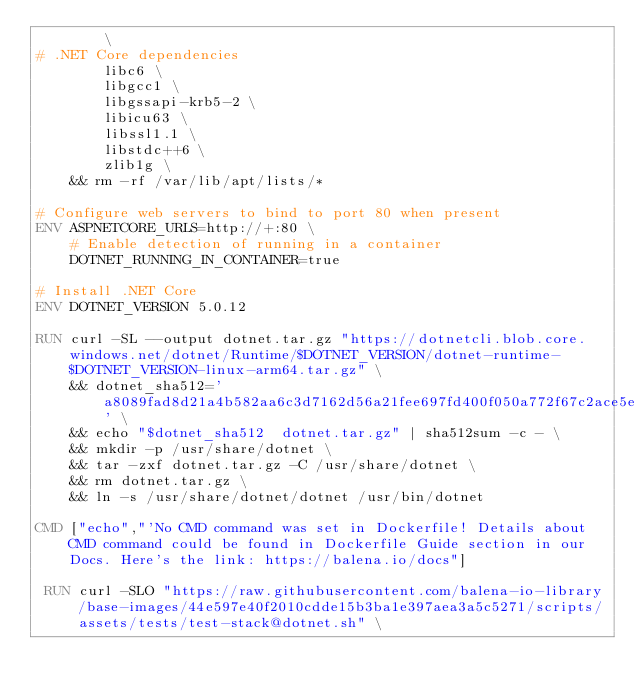<code> <loc_0><loc_0><loc_500><loc_500><_Dockerfile_>        \
# .NET Core dependencies
        libc6 \
        libgcc1 \
        libgssapi-krb5-2 \
        libicu63 \
        libssl1.1 \
        libstdc++6 \
        zlib1g \
    && rm -rf /var/lib/apt/lists/*

# Configure web servers to bind to port 80 when present
ENV ASPNETCORE_URLS=http://+:80 \
    # Enable detection of running in a container
    DOTNET_RUNNING_IN_CONTAINER=true

# Install .NET Core
ENV DOTNET_VERSION 5.0.12

RUN curl -SL --output dotnet.tar.gz "https://dotnetcli.blob.core.windows.net/dotnet/Runtime/$DOTNET_VERSION/dotnet-runtime-$DOTNET_VERSION-linux-arm64.tar.gz" \
    && dotnet_sha512='a8089fad8d21a4b582aa6c3d7162d56a21fee697fd400f050a772f67c2ace5e4196d1c4261d3e861d6dc2e5439666f112c406104d6271e5ab60cda80ef2ffc64' \
    && echo "$dotnet_sha512  dotnet.tar.gz" | sha512sum -c - \
    && mkdir -p /usr/share/dotnet \
    && tar -zxf dotnet.tar.gz -C /usr/share/dotnet \
    && rm dotnet.tar.gz \
    && ln -s /usr/share/dotnet/dotnet /usr/bin/dotnet

CMD ["echo","'No CMD command was set in Dockerfile! Details about CMD command could be found in Dockerfile Guide section in our Docs. Here's the link: https://balena.io/docs"]

 RUN curl -SLO "https://raw.githubusercontent.com/balena-io-library/base-images/44e597e40f2010cdde15b3ba1e397aea3a5c5271/scripts/assets/tests/test-stack@dotnet.sh" \</code> 